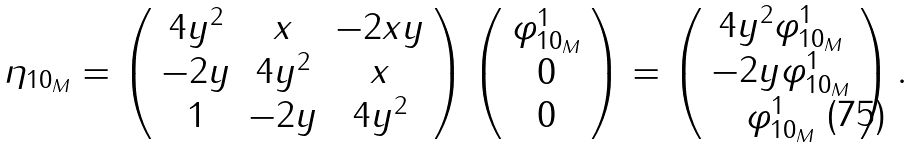<formula> <loc_0><loc_0><loc_500><loc_500>\eta _ { 1 0 _ { M } } = \left ( \begin{array} { c c c } 4 y ^ { 2 } & x & - 2 x y \\ - 2 y & 4 y ^ { 2 } & x \\ 1 & - 2 y & 4 y ^ { 2 } \end{array} \right ) \left ( \begin{array} { c } \varphi _ { 1 0 _ { M } } ^ { 1 } \\ 0 \\ 0 \end{array} \right ) = \left ( \begin{array} { c } 4 y ^ { 2 } \varphi _ { 1 0 _ { M } } ^ { 1 } \\ - 2 y \varphi _ { 1 0 _ { M } } ^ { 1 } \\ \varphi _ { 1 0 _ { M } } ^ { 1 } \end{array} \right ) .</formula> 